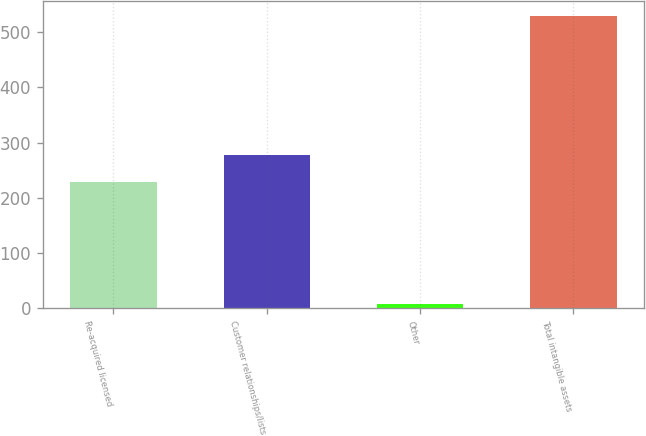Convert chart. <chart><loc_0><loc_0><loc_500><loc_500><bar_chart><fcel>Re-acquired licensed<fcel>Customer relationships/lists<fcel>Other<fcel>Total intangible assets<nl><fcel>229.4<fcel>277.69<fcel>7.4<fcel>529.79<nl></chart> 